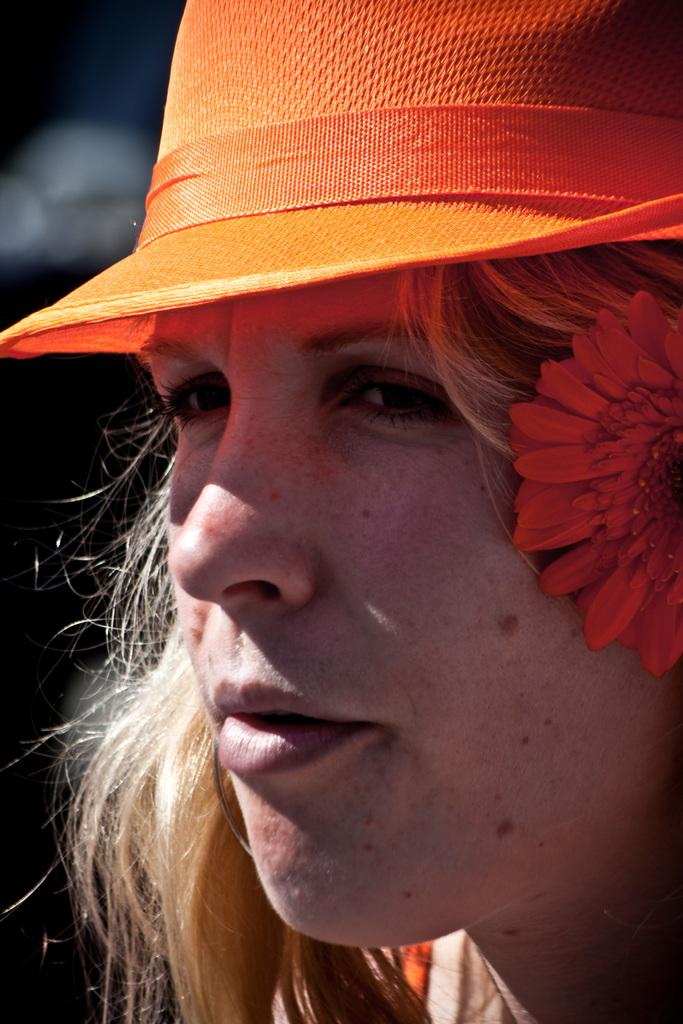What is the main subject of the image? The main subject of the image is a lady's face. What is the lady wearing in the image? The lady is wearing an orange hat in the image. What accessory does the lady have in the image? The lady has an orange flower in the image. What is the color of the background in the image? The background of the image is black. What type of form is the lady reading in the image? There is no form or reading activity depicted in the image; it features a lady's face with an orange flower and hat. How many circles can be seen in the image? There are no circles present in the image. 